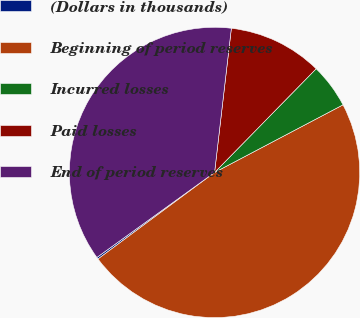Convert chart to OTSL. <chart><loc_0><loc_0><loc_500><loc_500><pie_chart><fcel>(Dollars in thousands)<fcel>Beginning of period reserves<fcel>Incurred losses<fcel>Paid losses<fcel>End of period reserves<nl><fcel>0.21%<fcel>47.55%<fcel>4.95%<fcel>10.49%<fcel>36.8%<nl></chart> 